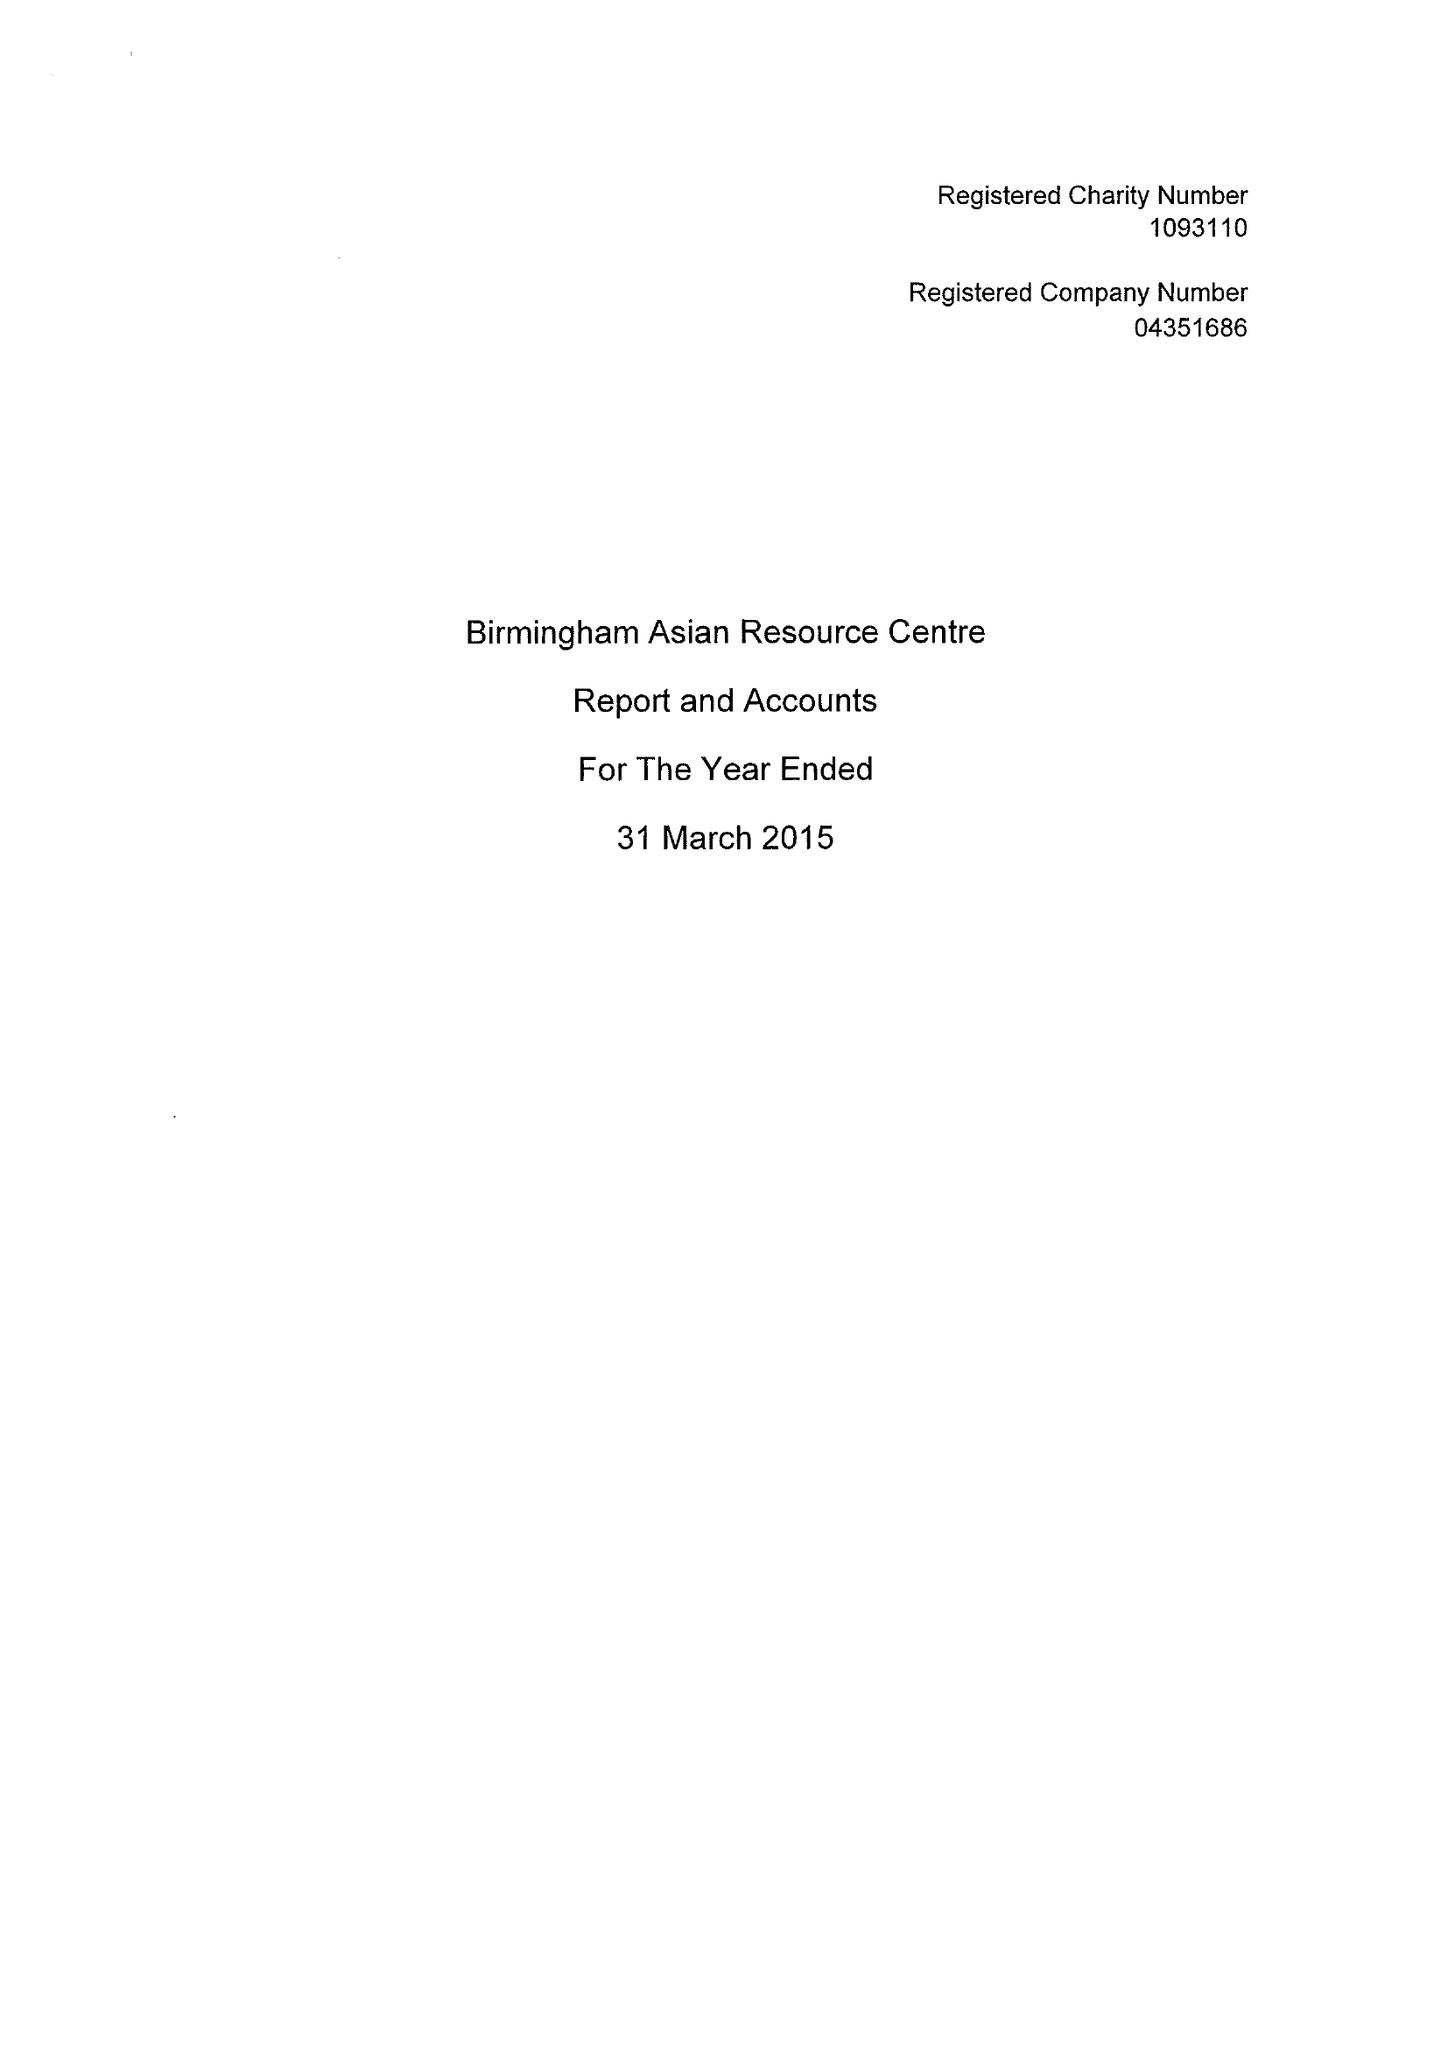What is the value for the income_annually_in_british_pounds?
Answer the question using a single word or phrase. 304992.00 